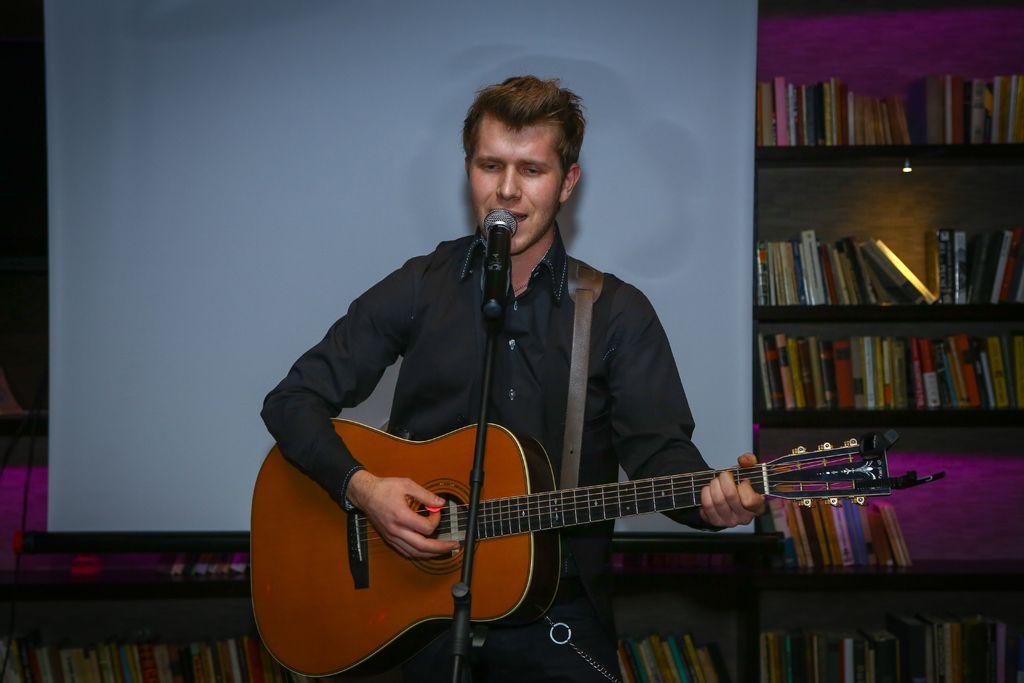How would you summarize this image in a sentence or two? The person wearing black shirt is singing and playing and playing guitar in front of a mike and there are book shelf and a projector in the background. 